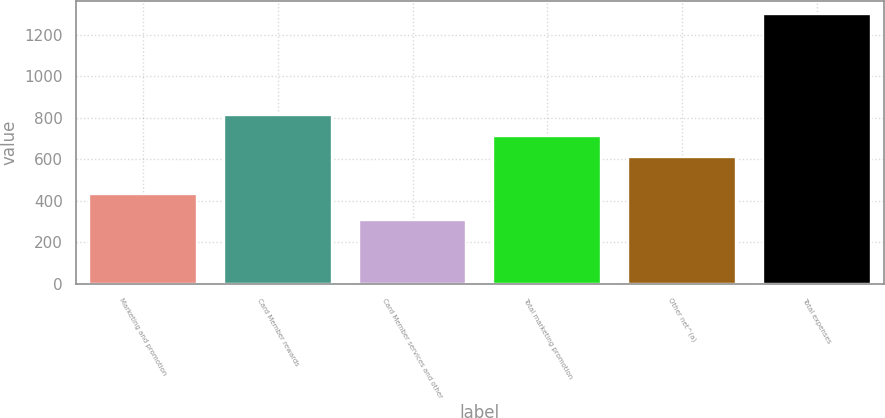Convert chart. <chart><loc_0><loc_0><loc_500><loc_500><bar_chart><fcel>Marketing and promotion<fcel>Card Member rewards<fcel>Card Member services and other<fcel>Total marketing promotion<fcel>Other net^(a)<fcel>Total expenses<nl><fcel>433<fcel>815<fcel>306<fcel>713.5<fcel>614<fcel>1301<nl></chart> 